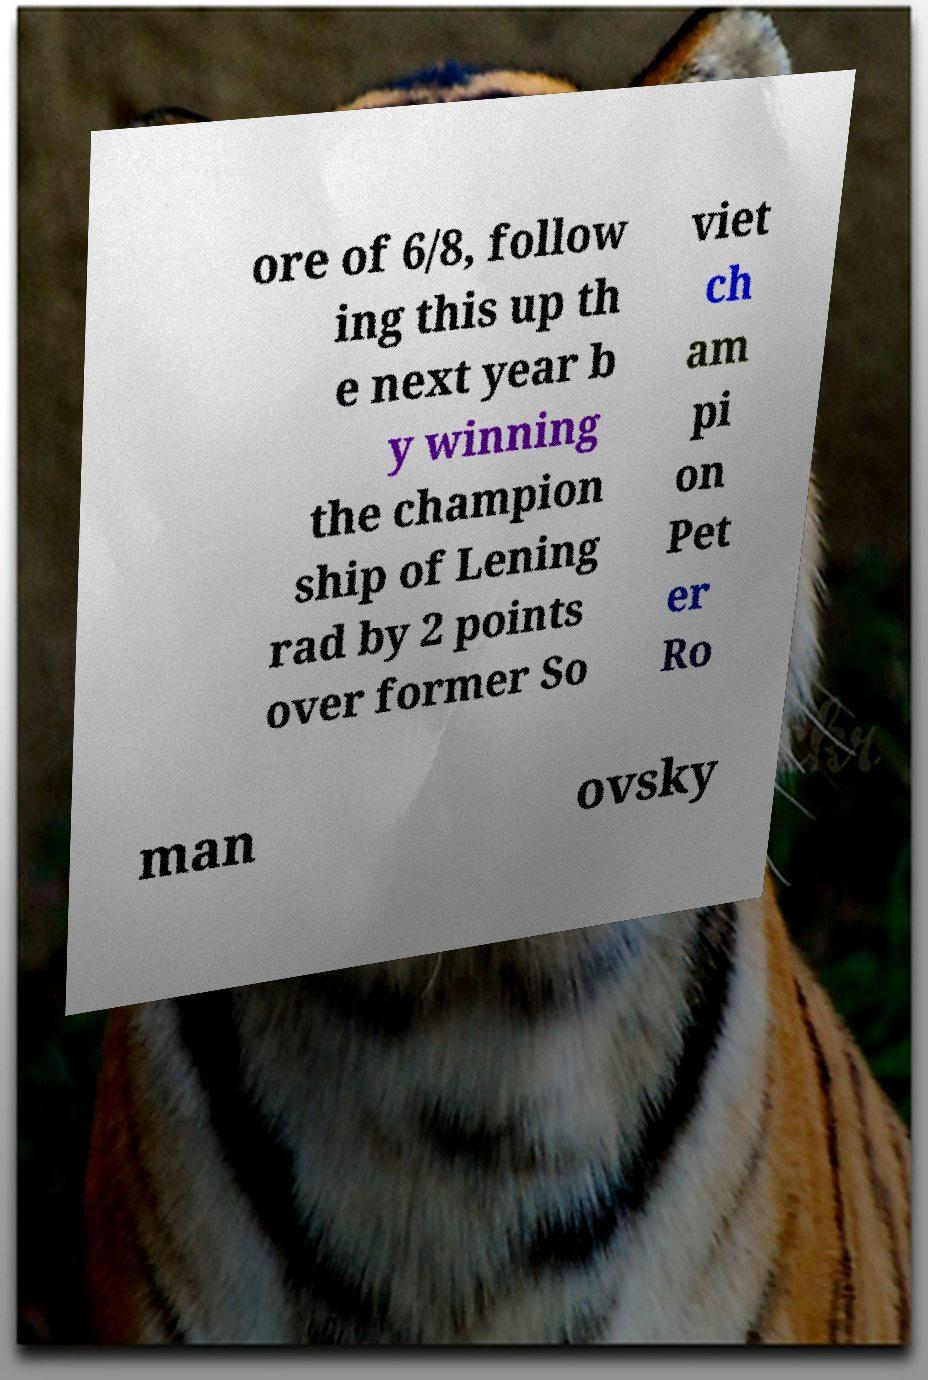Can you accurately transcribe the text from the provided image for me? ore of 6/8, follow ing this up th e next year b y winning the champion ship of Lening rad by 2 points over former So viet ch am pi on Pet er Ro man ovsky 